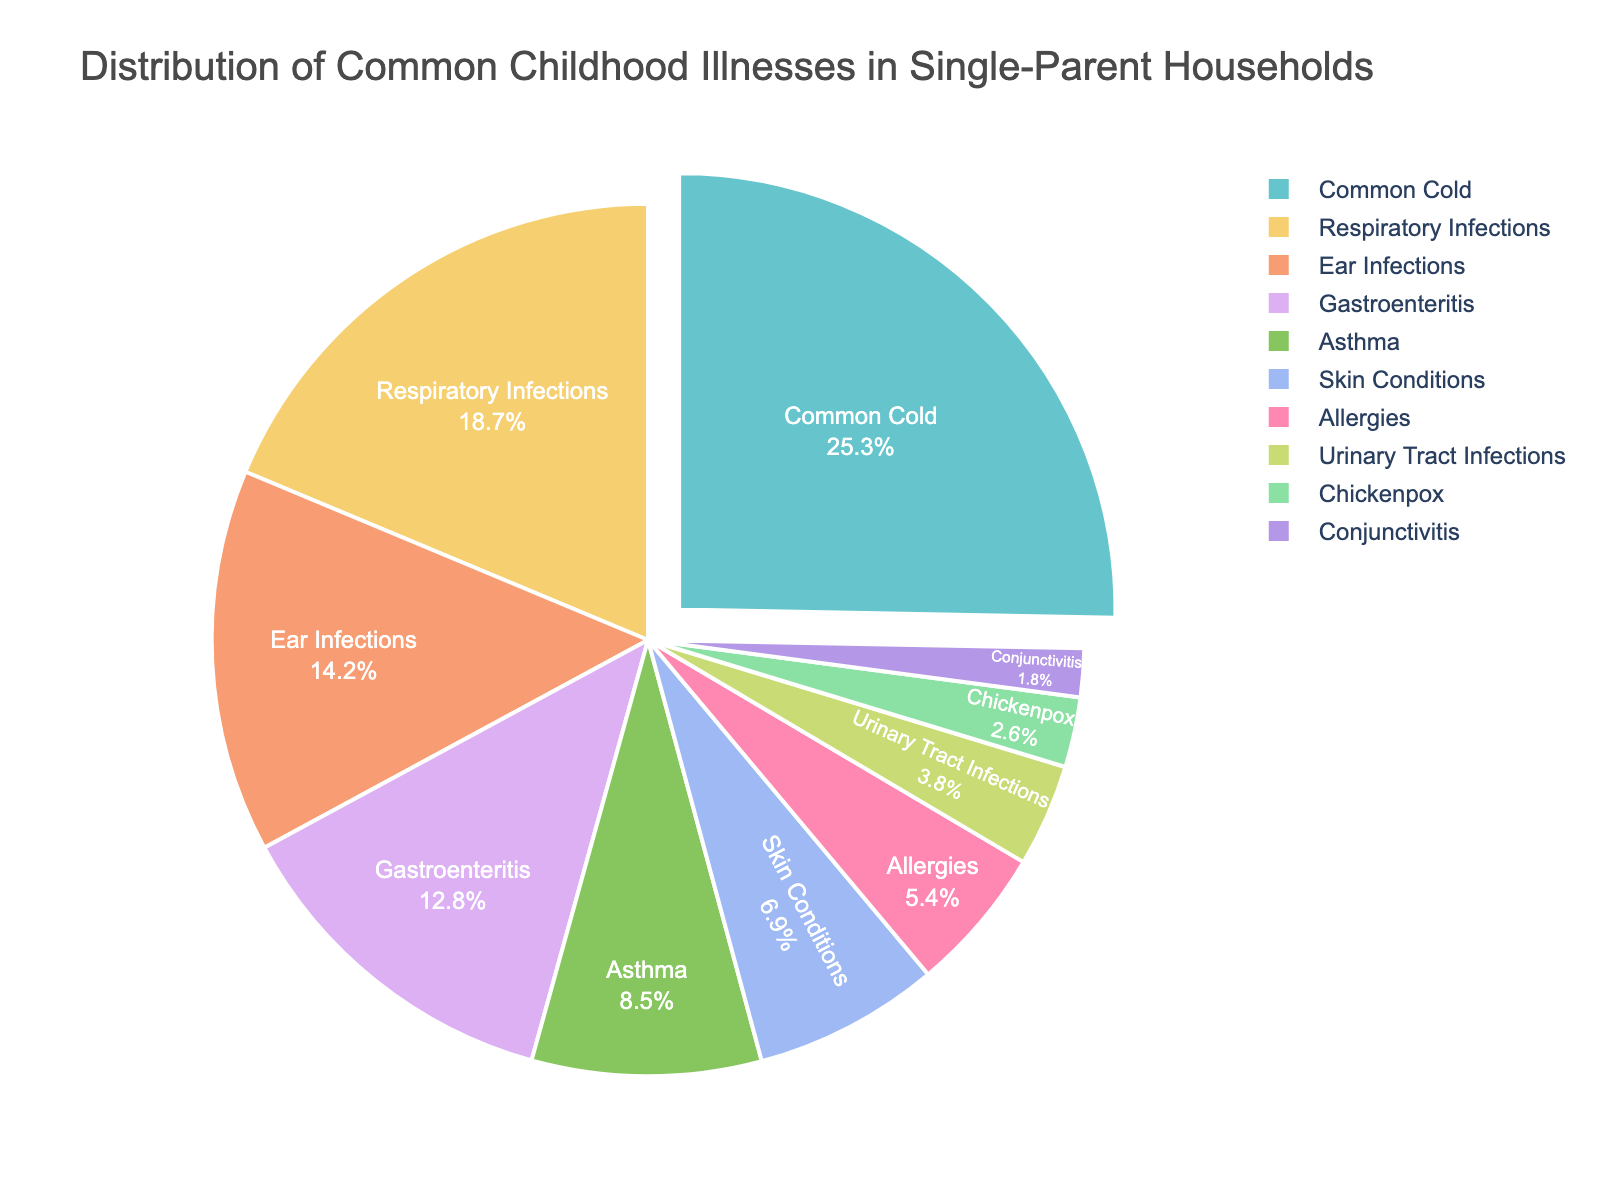Which illness has the highest percentage? To find the illness with the highest percentage, locate the largest section of the pie chart, which represents 25.3%. The corresponding label for this section is "Common Cold."
Answer: Common Cold What percentage of childhood illnesses in single-parent households does Respiratory Infections represent? Look at the section of the pie chart labeled "Respiratory Infections" and note the percentage value next to it, which is 18.7%.
Answer: 18.7% Are Skin Conditions more common than Asthma in single-parent households? Compare the percentage values of "Skin Conditions" (6.9%) and "Asthma" (8.5%) on the pie chart. Since 6.9% is less than 8.5%, Skin Conditions are less common than Asthma.
Answer: No What is the combined percentage of childhood illnesses represented by Ear Infections and Gastroenteritis? Find the percentages for "Ear Infections" (14.2%) and "Gastroenteritis" (12.8%) on the pie chart. Add these values together: 14.2% + 12.8% = 27%.
Answer: 27% Is the percentage of Gastroenteritis larger than that of Urinary Tract Infections? Compare the values of "Gastroenteritis" (12.8%) and "Urinary Tract Infections" (3.8%). Since 12.8% is greater than 3.8%, Gastroenteritis has a larger percentage.
Answer: Yes What is the difference in percentage between the most common and the least common illnesses? Identify the most common illness "Common Cold" (25.3%) and the least common "Conjunctivitis" (1.8%). Subtract the smaller value from the larger one: 25.3% - 1.8% = 23.5%.
Answer: 23.5% Which illnesses combined make up less than 10% of the distribution? Look at the sections of the pie chart labeled "Urinary Tract Infections" (3.8%), "Chickenpox" (2.6%), and "Conjunctivitis" (1.8%). Add these values together: 3.8% + 2.6% + 1.8% = 8.2%, which is less than 10%.
Answer: Urinary Tract Infections, Chickenpox, Conjunctivitis 